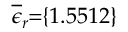Convert formula to latex. <formula><loc_0><loc_0><loc_500><loc_500>\, \overline { \epsilon } _ { r } \, = \, \{ 1 . 5 5 1 2 \} \,</formula> 